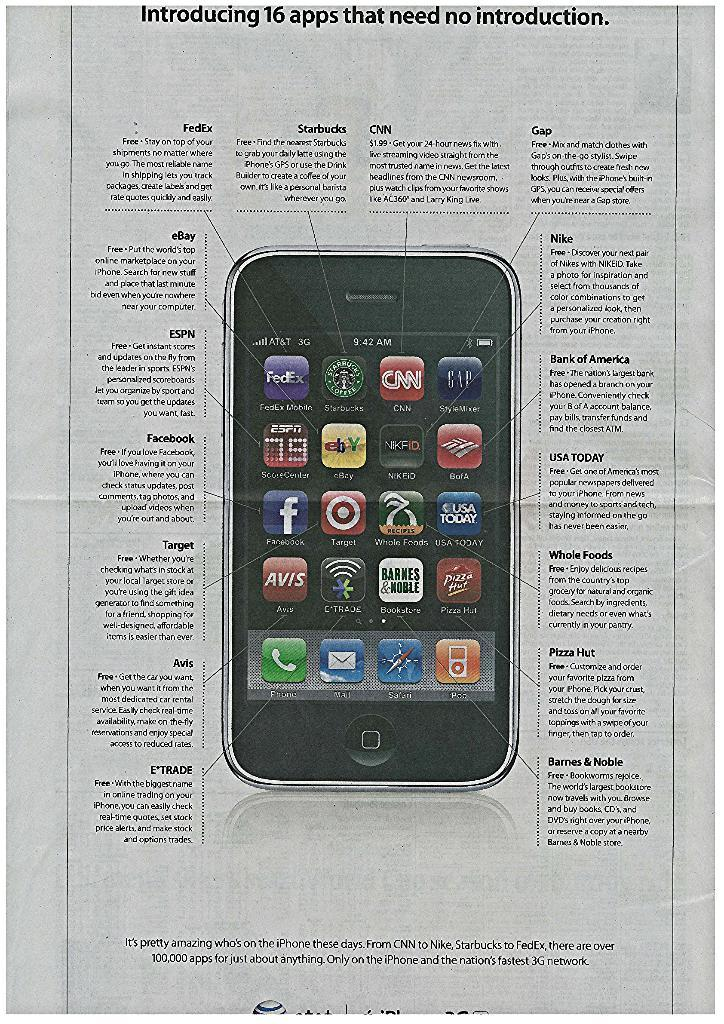What is present on the paper in the image? There is some text and an image of a mobile on the paper. Can you describe the image on the paper? The image on the paper is of a mobile. How is the text related to the image on the paper? The provided facts do not specify the relationship between the text and the image on the paper. What type of calendar is visible in the image? There is no calendar present in the image. How does the image of the mobile evoke a sense of disgust in the image? The image of the mobile does not evoke a sense of disgust in the image, as it is simply an image on a paper. 